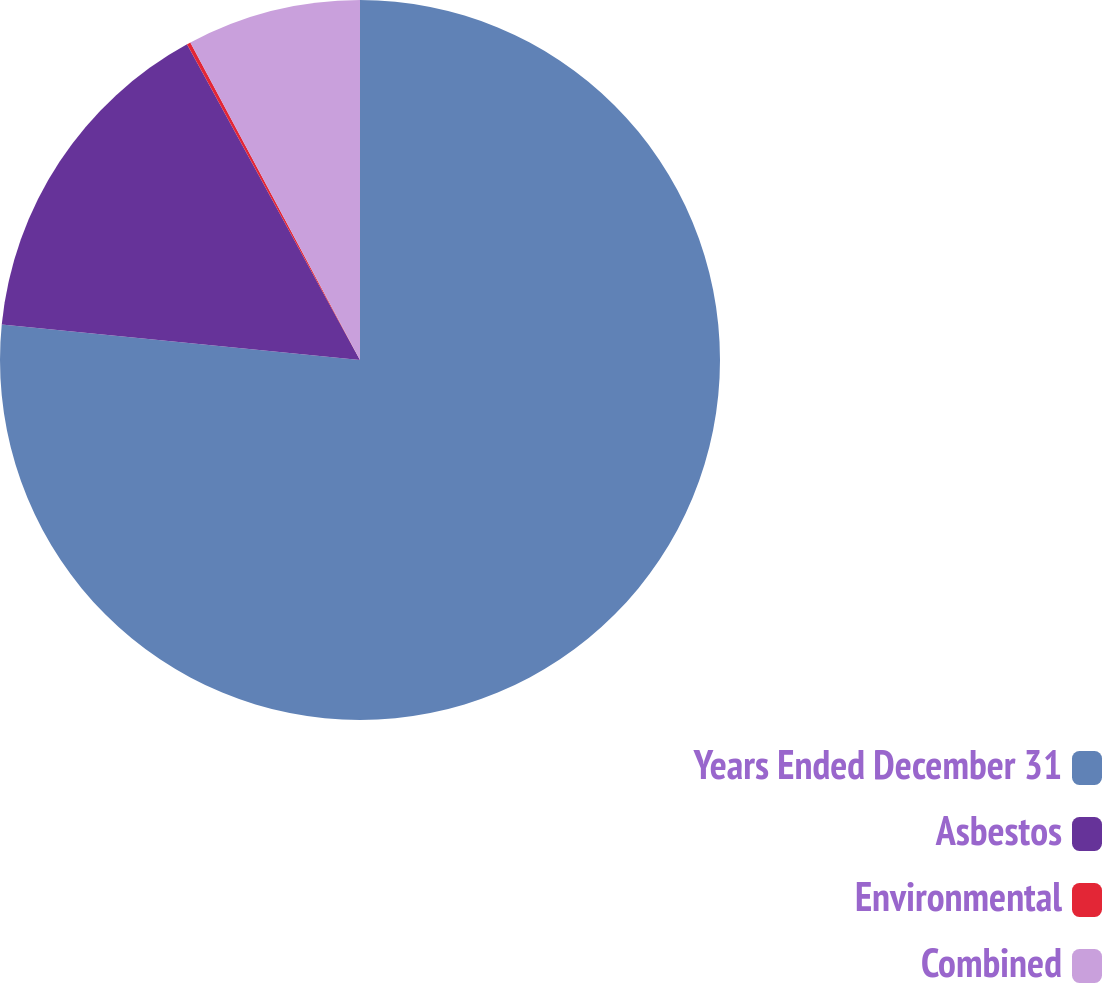Convert chart to OTSL. <chart><loc_0><loc_0><loc_500><loc_500><pie_chart><fcel>Years Ended December 31<fcel>Asbestos<fcel>Environmental<fcel>Combined<nl><fcel>76.58%<fcel>15.45%<fcel>0.17%<fcel>7.81%<nl></chart> 